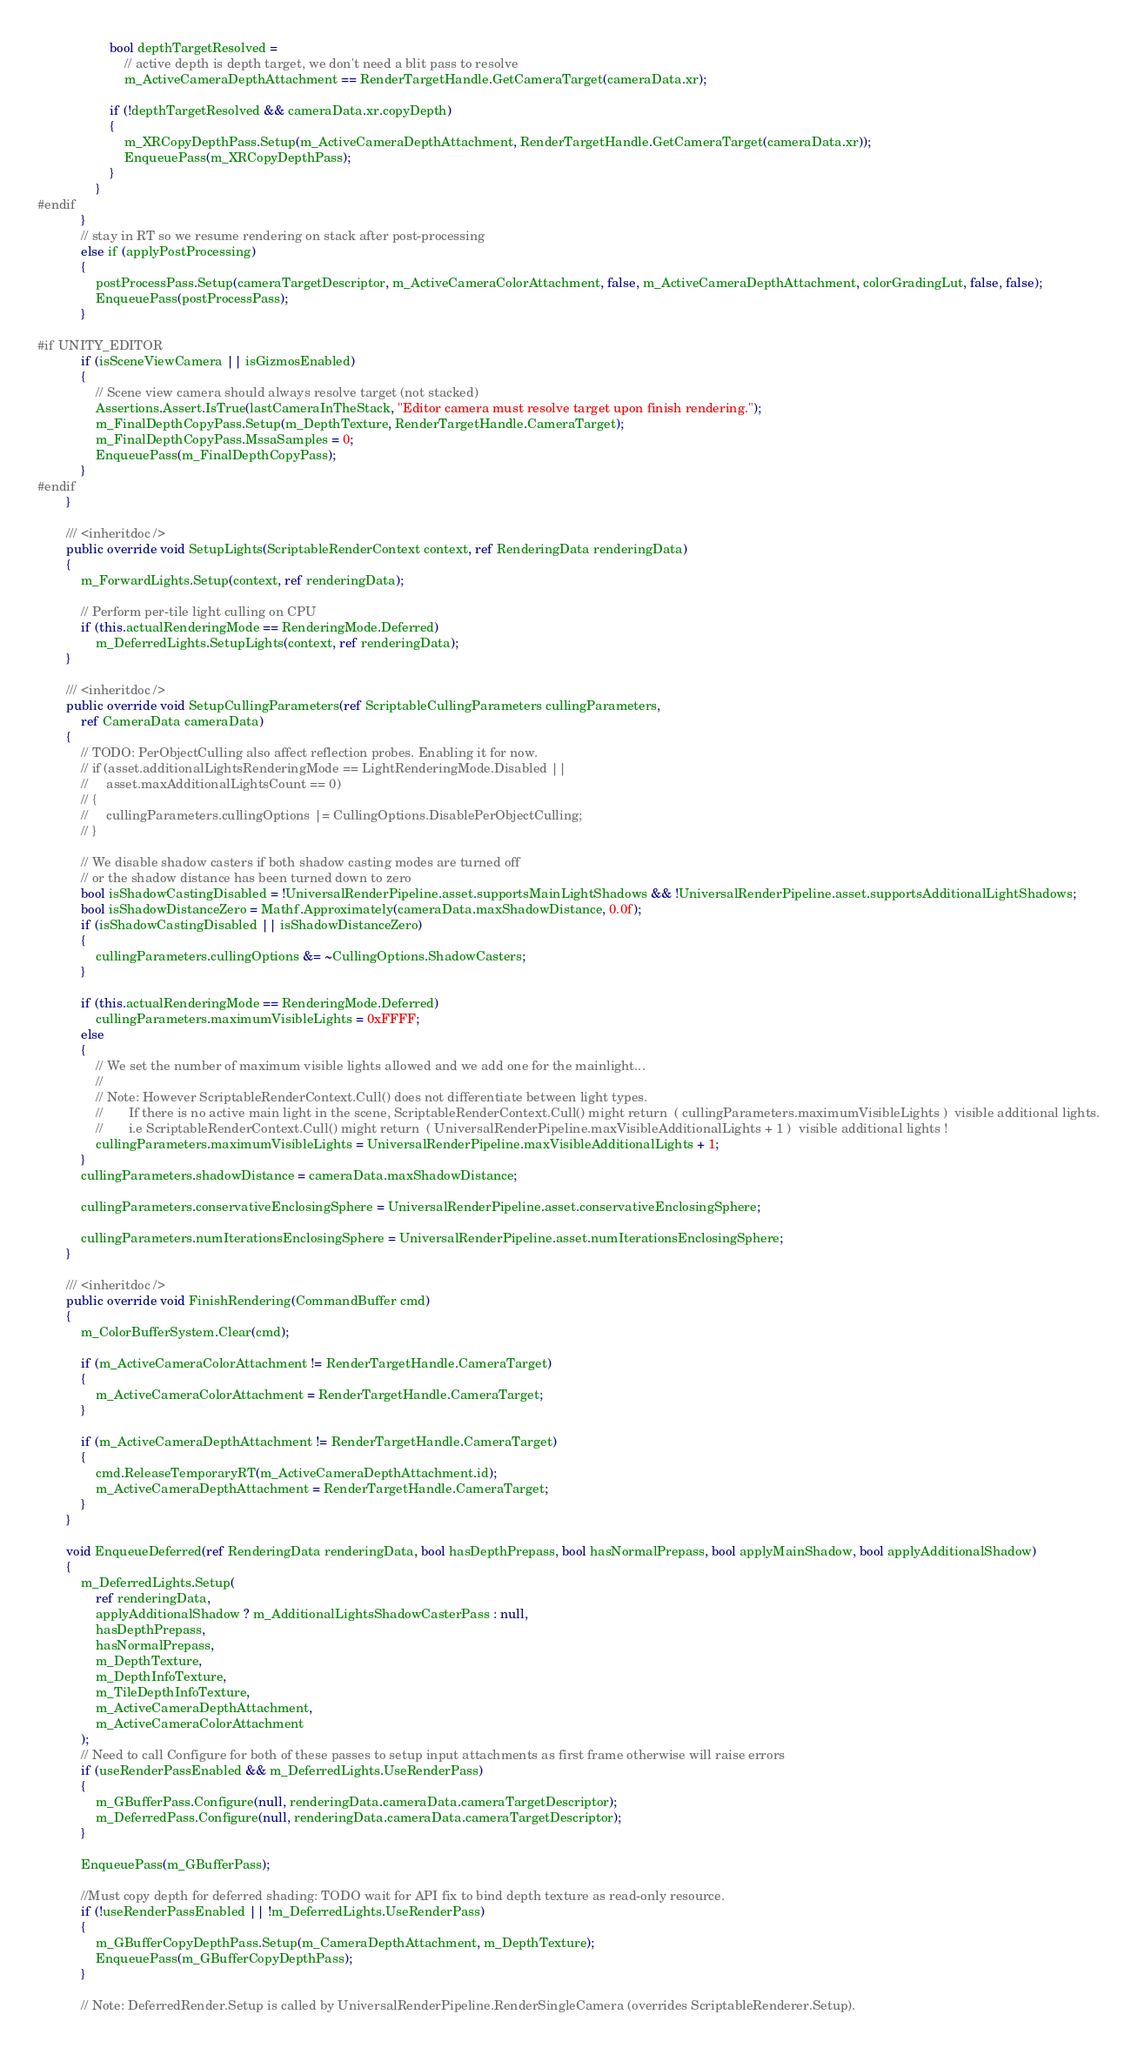Convert code to text. <code><loc_0><loc_0><loc_500><loc_500><_C#_>                    bool depthTargetResolved =
                        // active depth is depth target, we don't need a blit pass to resolve
                        m_ActiveCameraDepthAttachment == RenderTargetHandle.GetCameraTarget(cameraData.xr);

                    if (!depthTargetResolved && cameraData.xr.copyDepth)
                    {
                        m_XRCopyDepthPass.Setup(m_ActiveCameraDepthAttachment, RenderTargetHandle.GetCameraTarget(cameraData.xr));
                        EnqueuePass(m_XRCopyDepthPass);
                    }
                }
#endif
            }
            // stay in RT so we resume rendering on stack after post-processing
            else if (applyPostProcessing)
            {
                postProcessPass.Setup(cameraTargetDescriptor, m_ActiveCameraColorAttachment, false, m_ActiveCameraDepthAttachment, colorGradingLut, false, false);
                EnqueuePass(postProcessPass);
            }

#if UNITY_EDITOR
            if (isSceneViewCamera || isGizmosEnabled)
            {
                // Scene view camera should always resolve target (not stacked)
                Assertions.Assert.IsTrue(lastCameraInTheStack, "Editor camera must resolve target upon finish rendering.");
                m_FinalDepthCopyPass.Setup(m_DepthTexture, RenderTargetHandle.CameraTarget);
                m_FinalDepthCopyPass.MssaSamples = 0;
                EnqueuePass(m_FinalDepthCopyPass);
            }
#endif
        }

        /// <inheritdoc />
        public override void SetupLights(ScriptableRenderContext context, ref RenderingData renderingData)
        {
            m_ForwardLights.Setup(context, ref renderingData);

            // Perform per-tile light culling on CPU
            if (this.actualRenderingMode == RenderingMode.Deferred)
                m_DeferredLights.SetupLights(context, ref renderingData);
        }

        /// <inheritdoc />
        public override void SetupCullingParameters(ref ScriptableCullingParameters cullingParameters,
            ref CameraData cameraData)
        {
            // TODO: PerObjectCulling also affect reflection probes. Enabling it for now.
            // if (asset.additionalLightsRenderingMode == LightRenderingMode.Disabled ||
            //     asset.maxAdditionalLightsCount == 0)
            // {
            //     cullingParameters.cullingOptions |= CullingOptions.DisablePerObjectCulling;
            // }

            // We disable shadow casters if both shadow casting modes are turned off
            // or the shadow distance has been turned down to zero
            bool isShadowCastingDisabled = !UniversalRenderPipeline.asset.supportsMainLightShadows && !UniversalRenderPipeline.asset.supportsAdditionalLightShadows;
            bool isShadowDistanceZero = Mathf.Approximately(cameraData.maxShadowDistance, 0.0f);
            if (isShadowCastingDisabled || isShadowDistanceZero)
            {
                cullingParameters.cullingOptions &= ~CullingOptions.ShadowCasters;
            }

            if (this.actualRenderingMode == RenderingMode.Deferred)
                cullingParameters.maximumVisibleLights = 0xFFFF;
            else
            {
                // We set the number of maximum visible lights allowed and we add one for the mainlight...
                //
                // Note: However ScriptableRenderContext.Cull() does not differentiate between light types.
                //       If there is no active main light in the scene, ScriptableRenderContext.Cull() might return  ( cullingParameters.maximumVisibleLights )  visible additional lights.
                //       i.e ScriptableRenderContext.Cull() might return  ( UniversalRenderPipeline.maxVisibleAdditionalLights + 1 )  visible additional lights !
                cullingParameters.maximumVisibleLights = UniversalRenderPipeline.maxVisibleAdditionalLights + 1;
            }
            cullingParameters.shadowDistance = cameraData.maxShadowDistance;

            cullingParameters.conservativeEnclosingSphere = UniversalRenderPipeline.asset.conservativeEnclosingSphere;

            cullingParameters.numIterationsEnclosingSphere = UniversalRenderPipeline.asset.numIterationsEnclosingSphere;
        }

        /// <inheritdoc />
        public override void FinishRendering(CommandBuffer cmd)
        {
            m_ColorBufferSystem.Clear(cmd);

            if (m_ActiveCameraColorAttachment != RenderTargetHandle.CameraTarget)
            {
                m_ActiveCameraColorAttachment = RenderTargetHandle.CameraTarget;
            }

            if (m_ActiveCameraDepthAttachment != RenderTargetHandle.CameraTarget)
            {
                cmd.ReleaseTemporaryRT(m_ActiveCameraDepthAttachment.id);
                m_ActiveCameraDepthAttachment = RenderTargetHandle.CameraTarget;
            }
        }

        void EnqueueDeferred(ref RenderingData renderingData, bool hasDepthPrepass, bool hasNormalPrepass, bool applyMainShadow, bool applyAdditionalShadow)
        {
            m_DeferredLights.Setup(
                ref renderingData,
                applyAdditionalShadow ? m_AdditionalLightsShadowCasterPass : null,
                hasDepthPrepass,
                hasNormalPrepass,
                m_DepthTexture,
                m_DepthInfoTexture,
                m_TileDepthInfoTexture,
                m_ActiveCameraDepthAttachment,
                m_ActiveCameraColorAttachment
            );
            // Need to call Configure for both of these passes to setup input attachments as first frame otherwise will raise errors
            if (useRenderPassEnabled && m_DeferredLights.UseRenderPass)
            {
                m_GBufferPass.Configure(null, renderingData.cameraData.cameraTargetDescriptor);
                m_DeferredPass.Configure(null, renderingData.cameraData.cameraTargetDescriptor);
            }

            EnqueuePass(m_GBufferPass);

            //Must copy depth for deferred shading: TODO wait for API fix to bind depth texture as read-only resource.
            if (!useRenderPassEnabled || !m_DeferredLights.UseRenderPass)
            {
                m_GBufferCopyDepthPass.Setup(m_CameraDepthAttachment, m_DepthTexture);
                EnqueuePass(m_GBufferCopyDepthPass);
            }

            // Note: DeferredRender.Setup is called by UniversalRenderPipeline.RenderSingleCamera (overrides ScriptableRenderer.Setup).</code> 